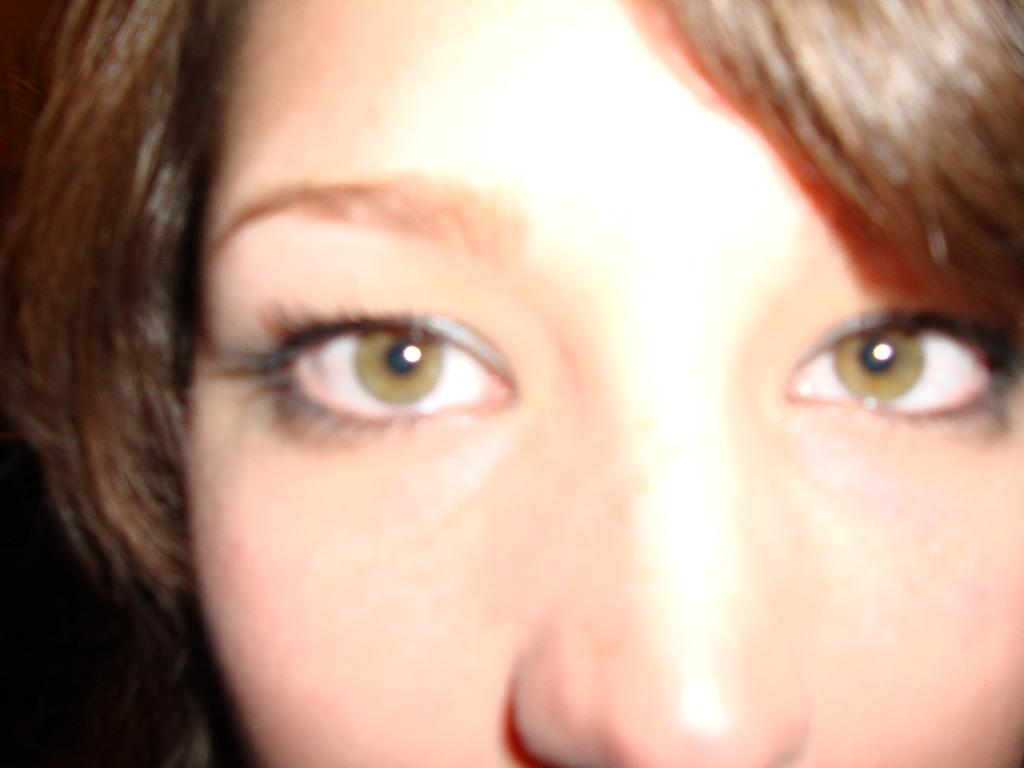What is the main subject of the image? There is a face of a person in the image. Can you see any visible veins on the person's face in the image? There is no information provided about the visibility of veins on the person's face in the image. 